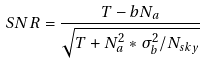<formula> <loc_0><loc_0><loc_500><loc_500>S N R = \frac { T - b N _ { a } } { \sqrt { T + N _ { a } ^ { 2 } * \sigma _ { b } ^ { 2 } / N _ { s k y } } }</formula> 